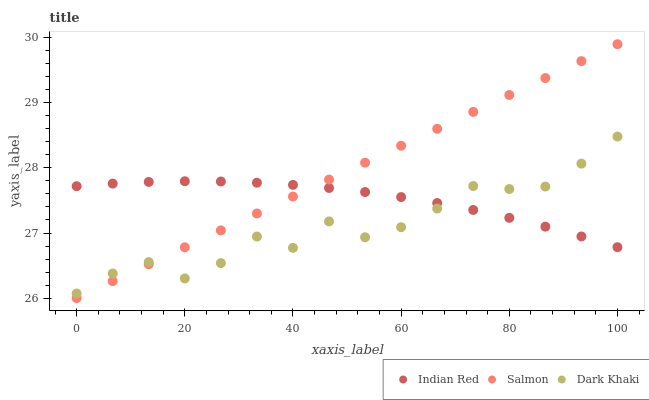Does Dark Khaki have the minimum area under the curve?
Answer yes or no. Yes. Does Salmon have the maximum area under the curve?
Answer yes or no. Yes. Does Indian Red have the minimum area under the curve?
Answer yes or no. No. Does Indian Red have the maximum area under the curve?
Answer yes or no. No. Is Salmon the smoothest?
Answer yes or no. Yes. Is Dark Khaki the roughest?
Answer yes or no. Yes. Is Indian Red the smoothest?
Answer yes or no. No. Is Indian Red the roughest?
Answer yes or no. No. Does Salmon have the lowest value?
Answer yes or no. Yes. Does Indian Red have the lowest value?
Answer yes or no. No. Does Salmon have the highest value?
Answer yes or no. Yes. Does Indian Red have the highest value?
Answer yes or no. No. Does Indian Red intersect Dark Khaki?
Answer yes or no. Yes. Is Indian Red less than Dark Khaki?
Answer yes or no. No. Is Indian Red greater than Dark Khaki?
Answer yes or no. No. 